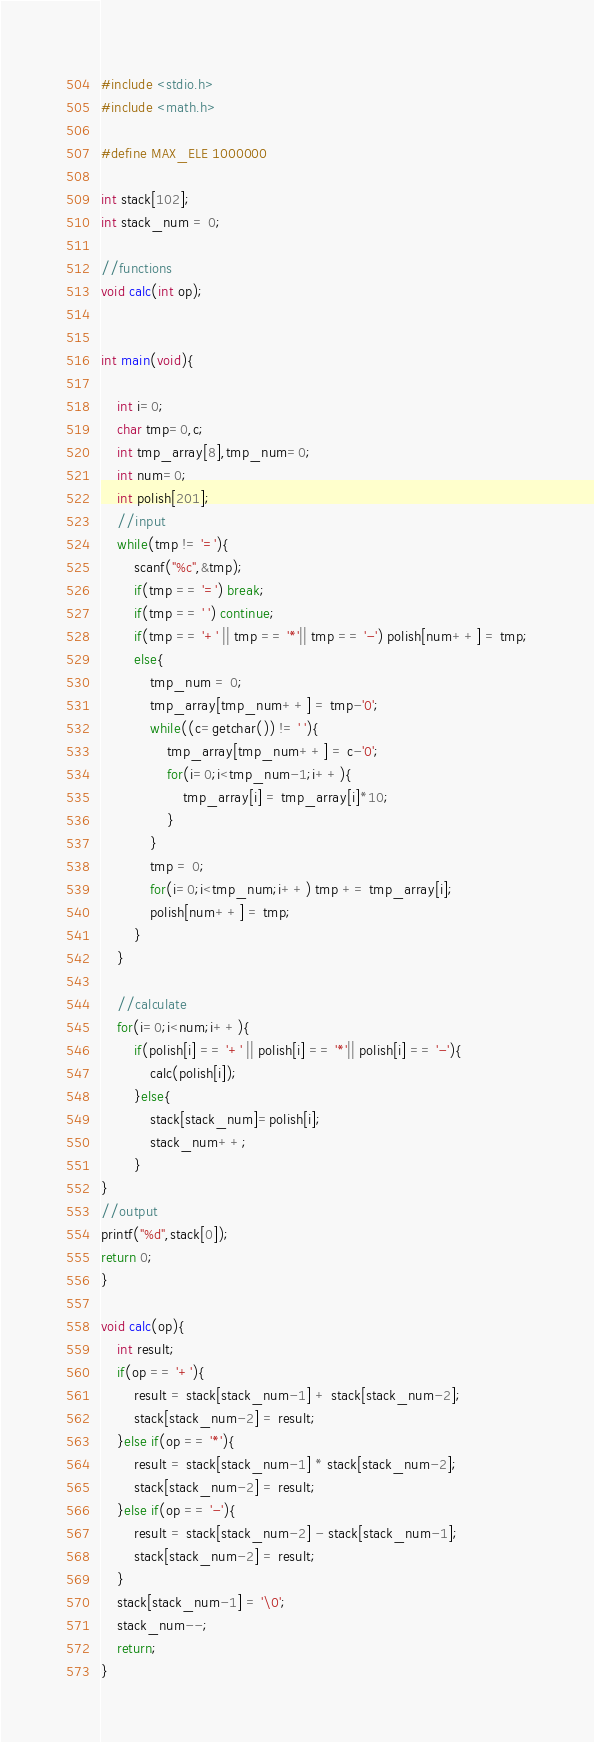<code> <loc_0><loc_0><loc_500><loc_500><_C_>#include <stdio.h>
#include <math.h>

#define MAX_ELE 1000000

int stack[102];
int stack_num = 0;

//functions
void calc(int op);


int main(void){

	int i=0;
	char tmp=0,c;
	int tmp_array[8],tmp_num=0;
	int num=0;
	int polish[201];
	//input
	while(tmp != '='){
		scanf("%c",&tmp);
		if(tmp == '=') break;
		if(tmp == ' ') continue;
		if(tmp == '+' || tmp == '*'|| tmp == '-') polish[num++] = tmp;
		else{
			tmp_num = 0;
			tmp_array[tmp_num++] = tmp-'0';
			while((c=getchar()) != ' '){
				tmp_array[tmp_num++] = c-'0';
				for(i=0;i<tmp_num-1;i++){
					tmp_array[i] = tmp_array[i]*10;
				}
			}
			tmp = 0;
			for(i=0;i<tmp_num;i++) tmp += tmp_array[i];
			polish[num++] = tmp;
		}
	}

	//calculate
	for(i=0;i<num;i++){
		if(polish[i] == '+' || polish[i] == '*'|| polish[i] == '-'){
			calc(polish[i]);
		}else{
			stack[stack_num]=polish[i];
			stack_num++;
		}
}
//output
printf("%d",stack[0]);
return 0;
}

void calc(op){
	int result;
	if(op == '+'){
		result = stack[stack_num-1] + stack[stack_num-2];
		stack[stack_num-2] = result;
	}else if(op == '*'){
		result = stack[stack_num-1] * stack[stack_num-2];
		stack[stack_num-2] = result;
	}else if(op == '-'){
		result = stack[stack_num-2] - stack[stack_num-1];
		stack[stack_num-2] = result;
	}
	stack[stack_num-1] = '\0';
	stack_num--;
	return;
}</code> 